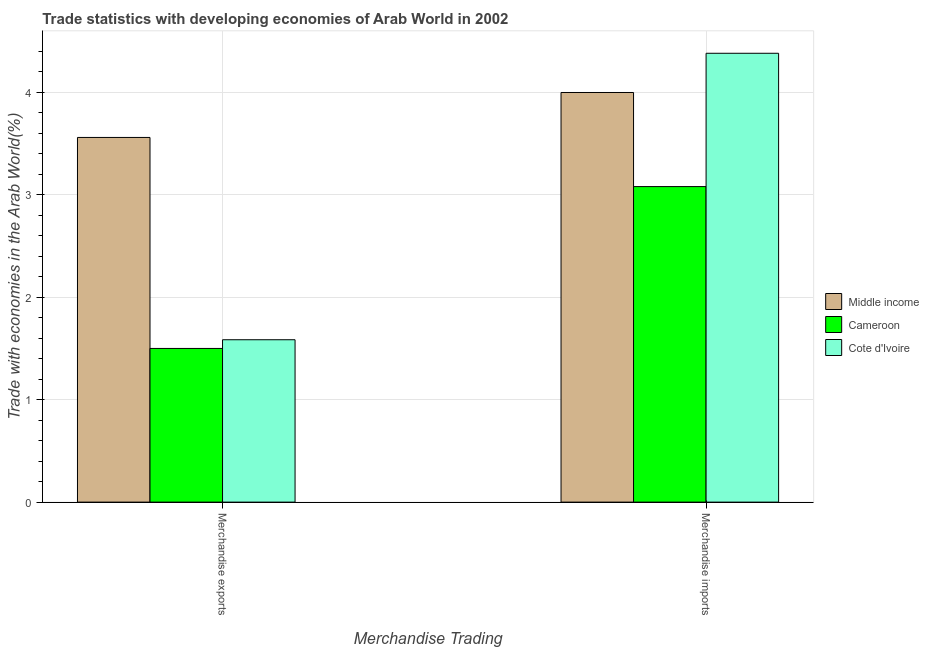How many different coloured bars are there?
Your answer should be very brief. 3. How many groups of bars are there?
Provide a succinct answer. 2. Are the number of bars per tick equal to the number of legend labels?
Your answer should be compact. Yes. How many bars are there on the 2nd tick from the left?
Provide a short and direct response. 3. How many bars are there on the 1st tick from the right?
Keep it short and to the point. 3. What is the merchandise exports in Middle income?
Ensure brevity in your answer.  3.56. Across all countries, what is the maximum merchandise exports?
Provide a succinct answer. 3.56. Across all countries, what is the minimum merchandise imports?
Give a very brief answer. 3.08. In which country was the merchandise exports maximum?
Keep it short and to the point. Middle income. In which country was the merchandise imports minimum?
Provide a short and direct response. Cameroon. What is the total merchandise imports in the graph?
Your answer should be compact. 11.46. What is the difference between the merchandise exports in Middle income and that in Cameroon?
Offer a very short reply. 2.06. What is the difference between the merchandise exports in Cameroon and the merchandise imports in Cote d'Ivoire?
Your response must be concise. -2.88. What is the average merchandise exports per country?
Provide a succinct answer. 2.21. What is the difference between the merchandise exports and merchandise imports in Cote d'Ivoire?
Your answer should be very brief. -2.8. In how many countries, is the merchandise exports greater than 0.4 %?
Give a very brief answer. 3. What is the ratio of the merchandise exports in Middle income to that in Cameroon?
Ensure brevity in your answer.  2.37. In how many countries, is the merchandise imports greater than the average merchandise imports taken over all countries?
Make the answer very short. 2. What does the 1st bar from the left in Merchandise imports represents?
Keep it short and to the point. Middle income. What does the 2nd bar from the right in Merchandise imports represents?
Your response must be concise. Cameroon. How many bars are there?
Give a very brief answer. 6. Are all the bars in the graph horizontal?
Your answer should be very brief. No. Are the values on the major ticks of Y-axis written in scientific E-notation?
Make the answer very short. No. Where does the legend appear in the graph?
Keep it short and to the point. Center right. What is the title of the graph?
Offer a very short reply. Trade statistics with developing economies of Arab World in 2002. What is the label or title of the X-axis?
Provide a succinct answer. Merchandise Trading. What is the label or title of the Y-axis?
Keep it short and to the point. Trade with economies in the Arab World(%). What is the Trade with economies in the Arab World(%) of Middle income in Merchandise exports?
Your answer should be very brief. 3.56. What is the Trade with economies in the Arab World(%) in Cameroon in Merchandise exports?
Offer a very short reply. 1.5. What is the Trade with economies in the Arab World(%) in Cote d'Ivoire in Merchandise exports?
Your response must be concise. 1.58. What is the Trade with economies in the Arab World(%) in Middle income in Merchandise imports?
Your answer should be very brief. 4. What is the Trade with economies in the Arab World(%) of Cameroon in Merchandise imports?
Provide a short and direct response. 3.08. What is the Trade with economies in the Arab World(%) of Cote d'Ivoire in Merchandise imports?
Ensure brevity in your answer.  4.38. Across all Merchandise Trading, what is the maximum Trade with economies in the Arab World(%) in Middle income?
Ensure brevity in your answer.  4. Across all Merchandise Trading, what is the maximum Trade with economies in the Arab World(%) of Cameroon?
Your answer should be very brief. 3.08. Across all Merchandise Trading, what is the maximum Trade with economies in the Arab World(%) in Cote d'Ivoire?
Offer a very short reply. 4.38. Across all Merchandise Trading, what is the minimum Trade with economies in the Arab World(%) of Middle income?
Offer a terse response. 3.56. Across all Merchandise Trading, what is the minimum Trade with economies in the Arab World(%) of Cameroon?
Provide a short and direct response. 1.5. Across all Merchandise Trading, what is the minimum Trade with economies in the Arab World(%) in Cote d'Ivoire?
Your answer should be very brief. 1.58. What is the total Trade with economies in the Arab World(%) of Middle income in the graph?
Give a very brief answer. 7.56. What is the total Trade with economies in the Arab World(%) of Cameroon in the graph?
Provide a succinct answer. 4.58. What is the total Trade with economies in the Arab World(%) of Cote d'Ivoire in the graph?
Keep it short and to the point. 5.96. What is the difference between the Trade with economies in the Arab World(%) in Middle income in Merchandise exports and that in Merchandise imports?
Give a very brief answer. -0.44. What is the difference between the Trade with economies in the Arab World(%) in Cameroon in Merchandise exports and that in Merchandise imports?
Make the answer very short. -1.58. What is the difference between the Trade with economies in the Arab World(%) in Cote d'Ivoire in Merchandise exports and that in Merchandise imports?
Your answer should be compact. -2.8. What is the difference between the Trade with economies in the Arab World(%) of Middle income in Merchandise exports and the Trade with economies in the Arab World(%) of Cameroon in Merchandise imports?
Offer a very short reply. 0.48. What is the difference between the Trade with economies in the Arab World(%) of Middle income in Merchandise exports and the Trade with economies in the Arab World(%) of Cote d'Ivoire in Merchandise imports?
Your answer should be compact. -0.82. What is the difference between the Trade with economies in the Arab World(%) in Cameroon in Merchandise exports and the Trade with economies in the Arab World(%) in Cote d'Ivoire in Merchandise imports?
Ensure brevity in your answer.  -2.88. What is the average Trade with economies in the Arab World(%) in Middle income per Merchandise Trading?
Make the answer very short. 3.78. What is the average Trade with economies in the Arab World(%) in Cameroon per Merchandise Trading?
Your answer should be very brief. 2.29. What is the average Trade with economies in the Arab World(%) in Cote d'Ivoire per Merchandise Trading?
Offer a terse response. 2.98. What is the difference between the Trade with economies in the Arab World(%) of Middle income and Trade with economies in the Arab World(%) of Cameroon in Merchandise exports?
Provide a short and direct response. 2.06. What is the difference between the Trade with economies in the Arab World(%) of Middle income and Trade with economies in the Arab World(%) of Cote d'Ivoire in Merchandise exports?
Your answer should be compact. 1.97. What is the difference between the Trade with economies in the Arab World(%) in Cameroon and Trade with economies in the Arab World(%) in Cote d'Ivoire in Merchandise exports?
Give a very brief answer. -0.09. What is the difference between the Trade with economies in the Arab World(%) of Middle income and Trade with economies in the Arab World(%) of Cameroon in Merchandise imports?
Your response must be concise. 0.92. What is the difference between the Trade with economies in the Arab World(%) in Middle income and Trade with economies in the Arab World(%) in Cote d'Ivoire in Merchandise imports?
Give a very brief answer. -0.38. What is the difference between the Trade with economies in the Arab World(%) of Cameroon and Trade with economies in the Arab World(%) of Cote d'Ivoire in Merchandise imports?
Offer a very short reply. -1.3. What is the ratio of the Trade with economies in the Arab World(%) in Middle income in Merchandise exports to that in Merchandise imports?
Offer a very short reply. 0.89. What is the ratio of the Trade with economies in the Arab World(%) in Cameroon in Merchandise exports to that in Merchandise imports?
Provide a short and direct response. 0.49. What is the ratio of the Trade with economies in the Arab World(%) in Cote d'Ivoire in Merchandise exports to that in Merchandise imports?
Ensure brevity in your answer.  0.36. What is the difference between the highest and the second highest Trade with economies in the Arab World(%) of Middle income?
Give a very brief answer. 0.44. What is the difference between the highest and the second highest Trade with economies in the Arab World(%) in Cameroon?
Your response must be concise. 1.58. What is the difference between the highest and the second highest Trade with economies in the Arab World(%) of Cote d'Ivoire?
Make the answer very short. 2.8. What is the difference between the highest and the lowest Trade with economies in the Arab World(%) in Middle income?
Make the answer very short. 0.44. What is the difference between the highest and the lowest Trade with economies in the Arab World(%) in Cameroon?
Make the answer very short. 1.58. What is the difference between the highest and the lowest Trade with economies in the Arab World(%) of Cote d'Ivoire?
Give a very brief answer. 2.8. 